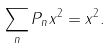Convert formula to latex. <formula><loc_0><loc_0><loc_500><loc_500>\sum _ { n } \| P _ { n } x \| ^ { 2 } = \| x \| ^ { 2 } .</formula> 